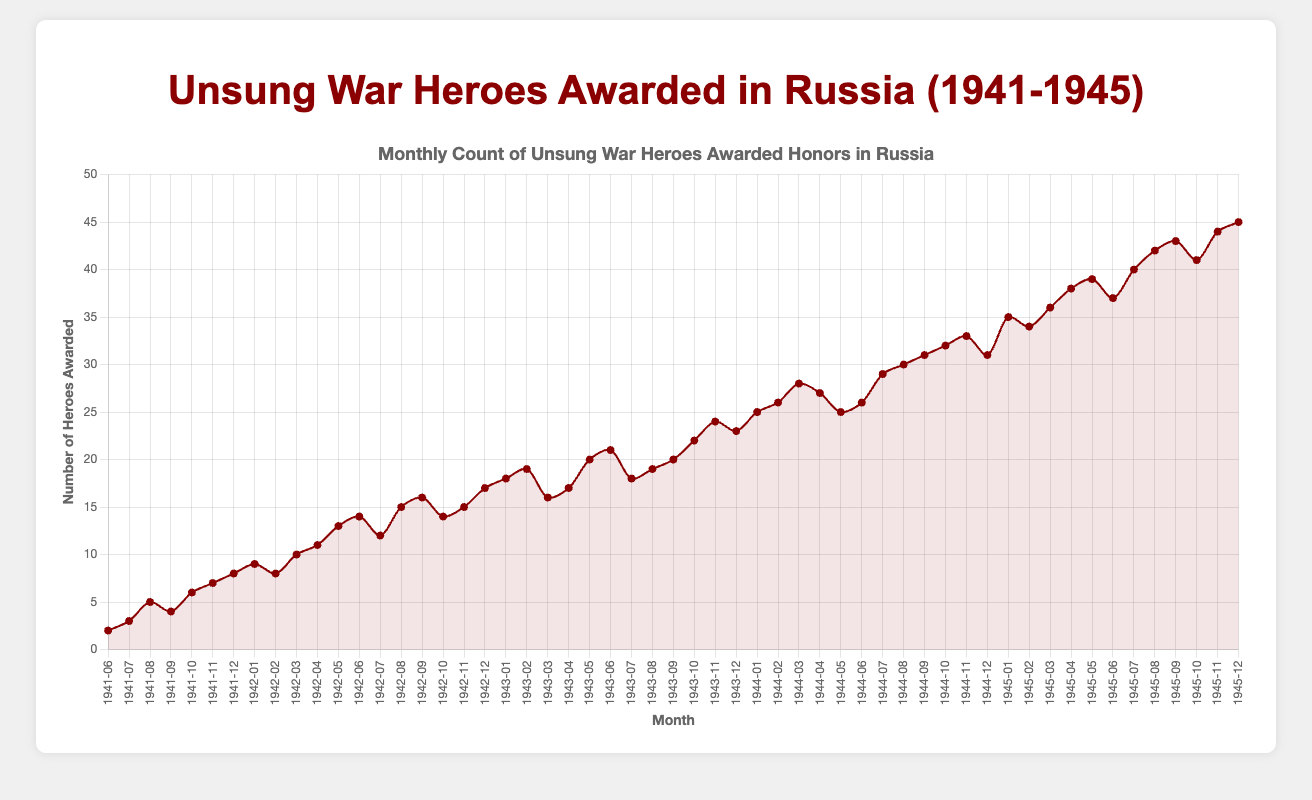What month experienced the highest number of unsung war heroes awarded? To find the month with the highest count, observe the peak point on the line chart. Here, the highest point corresponds to December 1945 with 45 awards.
Answer: December 1945 How did the number of awards change from June 1942 to May 1943? Compare the values at June 1942 and May 1943 on the chart. June 1942 had 14 awards, and May 1943 had 21 awards, indicating an increase.
Answer: Increased by 7 During which year did the initial increase in awarded heroes slow down the most? Look for a year where the rate of increase in awarded heroes flattens or slows compared to previous years. Between 1944-1945, the increase appears less steep compared to previous years.
Answer: 1944 What is the average number of unsung war heroes awarded honors in 1943? Sum the monthly awards in 1943 (18 + 19 + 16 + 17 + 20 + 21 + 18 + 19 + 20 + 22 + 24 + 23 = 237) and divide by 12 (months). 237 / 12 = 19.75.
Answer: 19.75 How many times did the count of awarded heroes exceed 30 in 1945? Identify months in 1945 where the value surpasses 30. Months are April (38), May (39), July (40), August (42), September (43), November (44), and December (45).
Answer: 7 times What is the difference in the number of awarded heroes between the start and end of 1942? Compare the values for January 1942 and December 1942. January 1942 had 9 awards, December 1942 had 17 awards. Difference = 17 - 9 = 8.
Answer: 8 Which month in 1943 saw a drop in awards from the previous month? Identify any decrease from month to month in 1943. March to April showed 19 dropping to 16.
Answer: April 1943 What month saw the highest single-month increase in awarded heroes? Observe the monthly differences and look for the maximum increase. From October to November 1945, there was an increase from 40 to 44, showing the highest jump by 4 awards.
Answer: November 1945 How does the total number of awards in 1941 compare to 1942? Sum the monthly awards for each year and compare. 1941 total = 2+3+5+4+6+7+8 = 35, 1942 total = 9+8+10+11+13+14+12+15+16+14+15+17 = 144.
Answer: 35 in 1941, 144 in 1942 Which year saw the smallest monthly award count, and in which month? Identify the smallest count across all years and note the corresponding month and year. June 1941 had the smallest count with 2 awards.
Answer: June 1941 